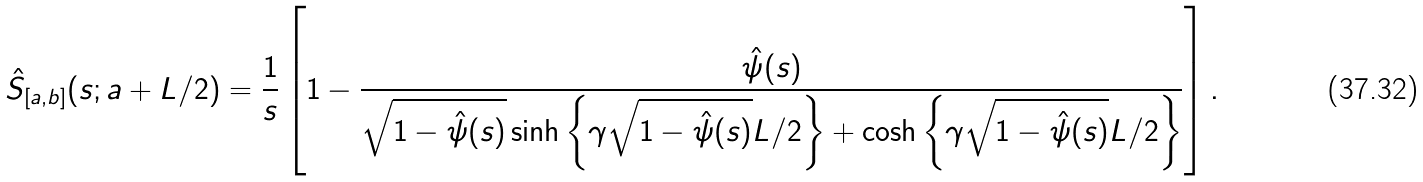Convert formula to latex. <formula><loc_0><loc_0><loc_500><loc_500>\hat { S } _ { [ a , b ] } ( s ; a + L / 2 ) = \frac { 1 } { s } \left [ { 1 - \frac { \hat { \psi } ( s ) } { { \sqrt { 1 - \hat { \psi } ( s ) } \sinh \left \{ \gamma \sqrt { 1 - \hat { \psi } ( s ) } L / 2 \right \} + \cosh \left \{ \gamma \sqrt { 1 - \hat { \psi } ( s ) } L / 2 \right \} } } } \right ] .</formula> 